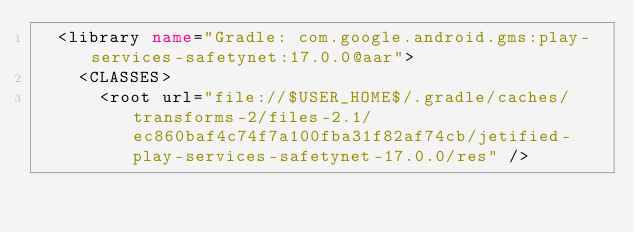Convert code to text. <code><loc_0><loc_0><loc_500><loc_500><_XML_>  <library name="Gradle: com.google.android.gms:play-services-safetynet:17.0.0@aar">
    <CLASSES>
      <root url="file://$USER_HOME$/.gradle/caches/transforms-2/files-2.1/ec860baf4c74f7a100fba31f82af74cb/jetified-play-services-safetynet-17.0.0/res" /></code> 